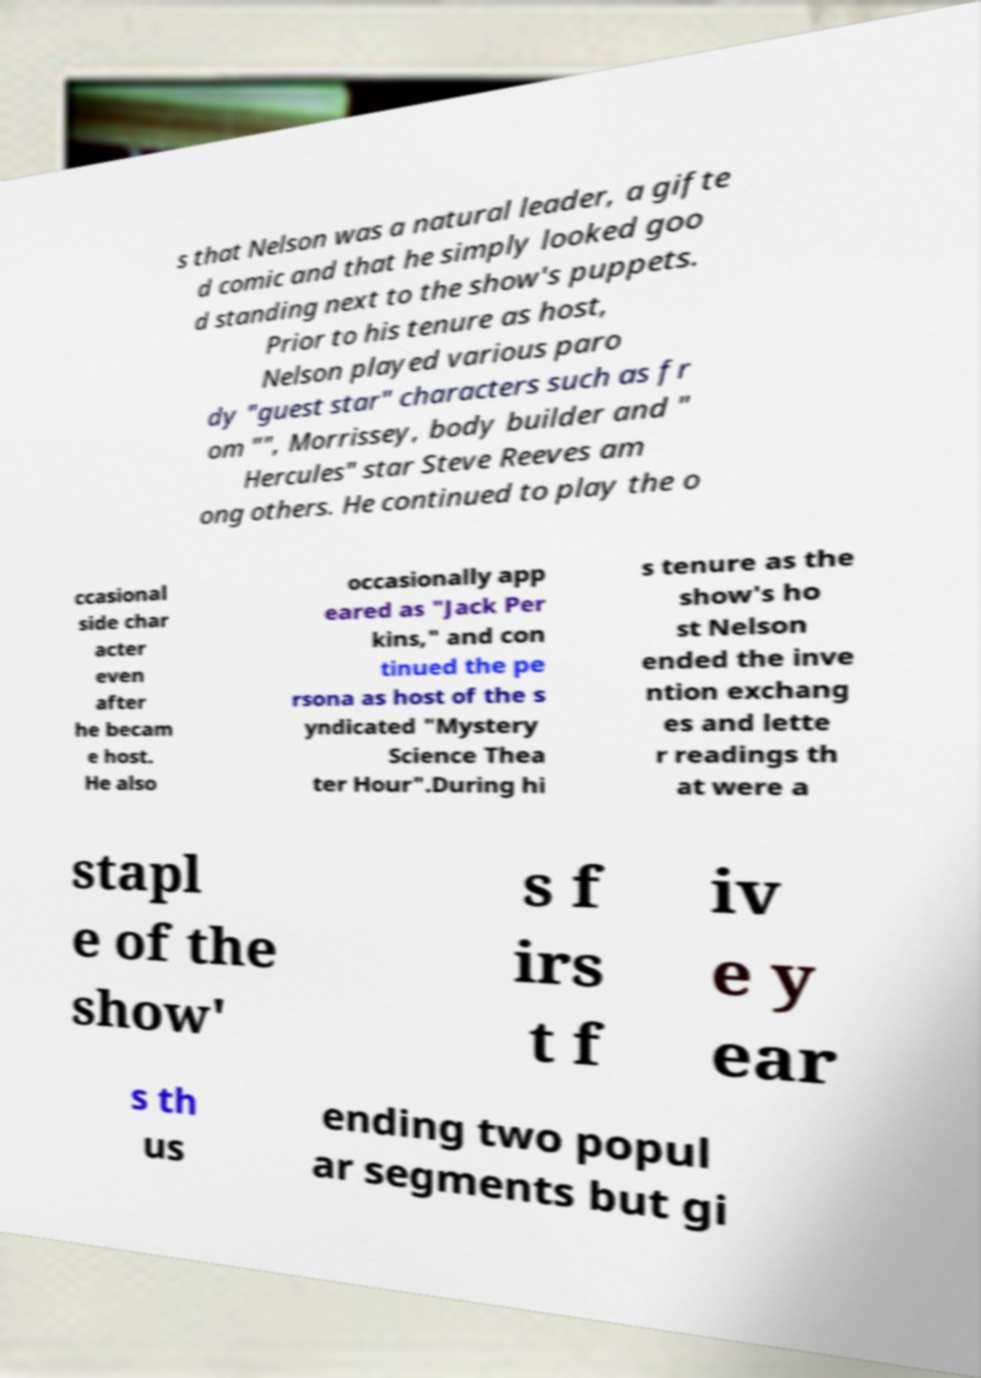I need the written content from this picture converted into text. Can you do that? s that Nelson was a natural leader, a gifte d comic and that he simply looked goo d standing next to the show's puppets. Prior to his tenure as host, Nelson played various paro dy "guest star" characters such as fr om "", Morrissey, body builder and " Hercules" star Steve Reeves am ong others. He continued to play the o ccasional side char acter even after he becam e host. He also occasionally app eared as "Jack Per kins," and con tinued the pe rsona as host of the s yndicated "Mystery Science Thea ter Hour".During hi s tenure as the show's ho st Nelson ended the inve ntion exchang es and lette r readings th at were a stapl e of the show' s f irs t f iv e y ear s th us ending two popul ar segments but gi 